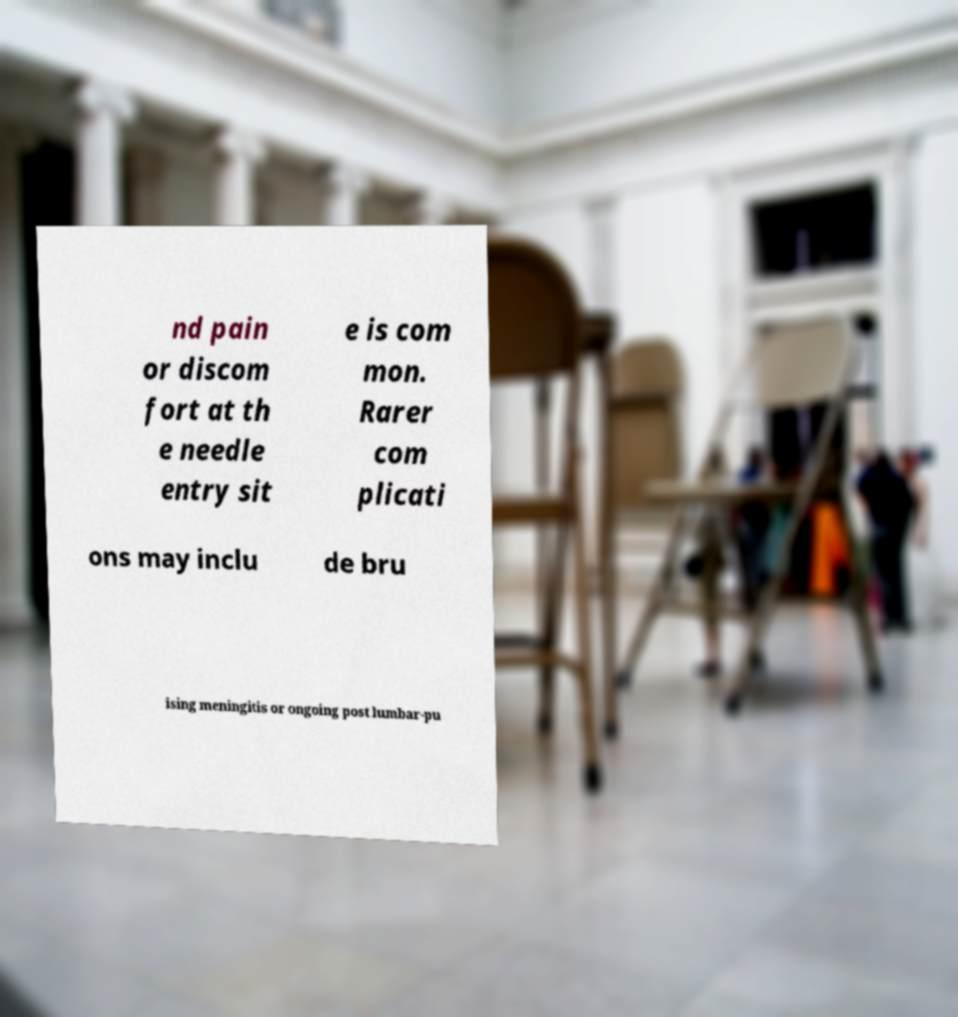Can you read and provide the text displayed in the image?This photo seems to have some interesting text. Can you extract and type it out for me? nd pain or discom fort at th e needle entry sit e is com mon. Rarer com plicati ons may inclu de bru ising meningitis or ongoing post lumbar-pu 